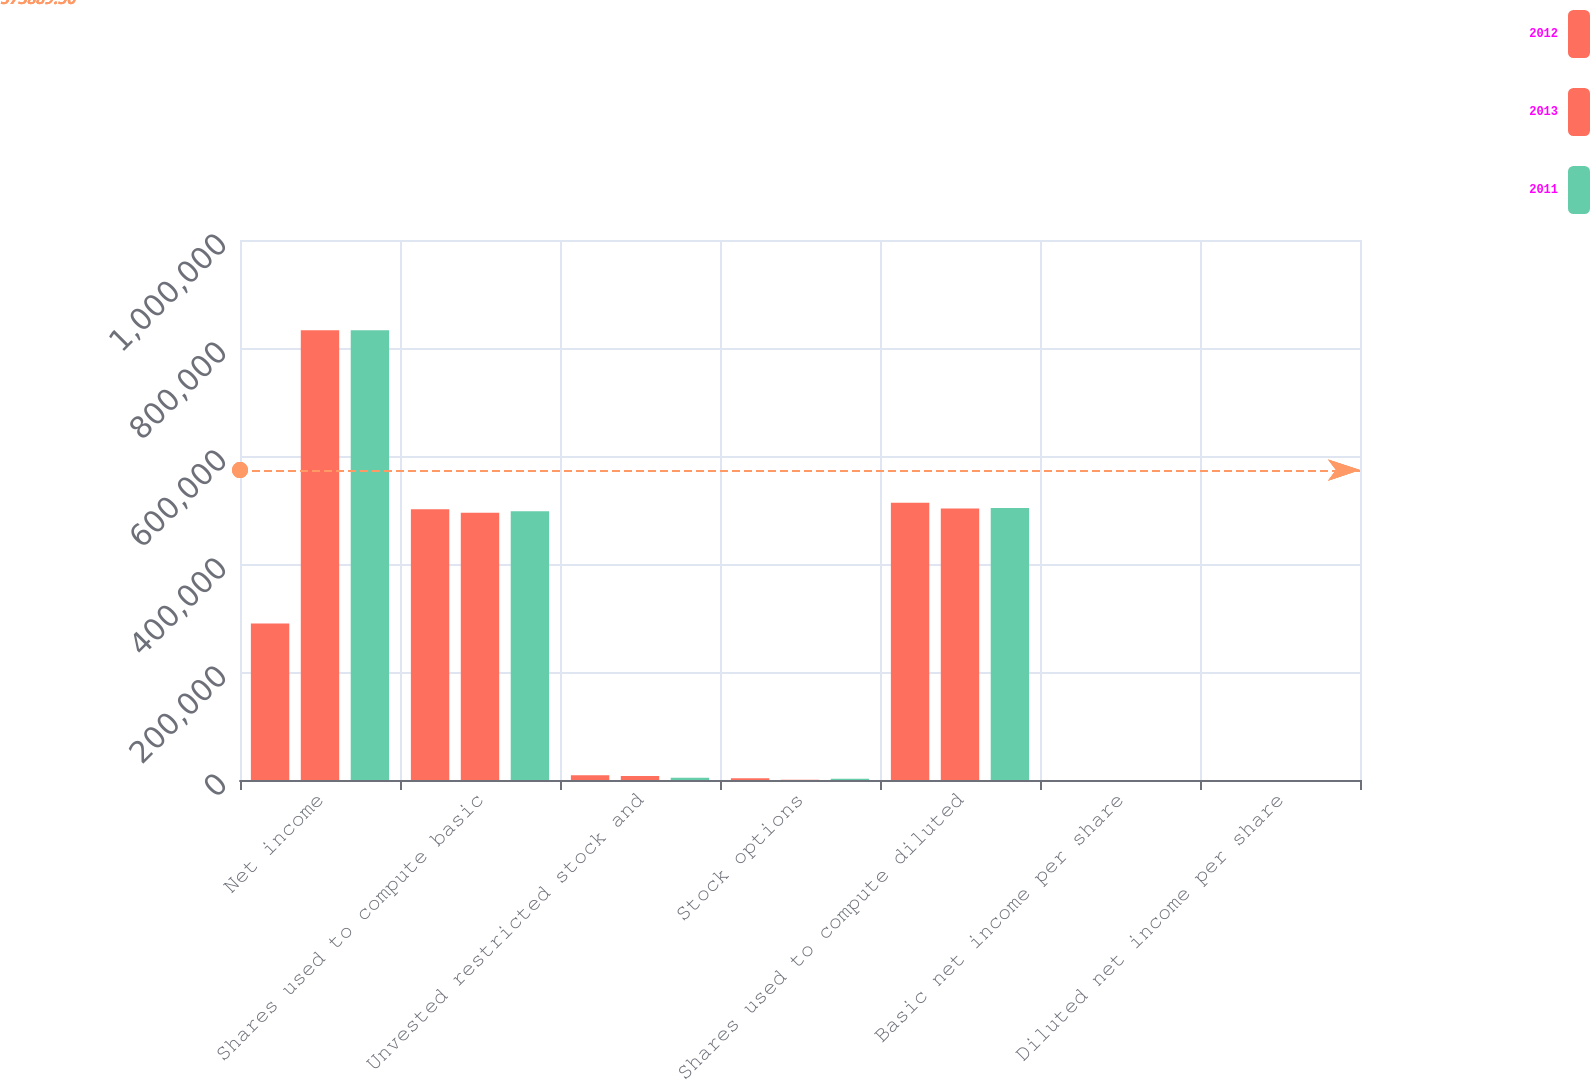<chart> <loc_0><loc_0><loc_500><loc_500><stacked_bar_chart><ecel><fcel>Net income<fcel>Shares used to compute basic<fcel>Unvested restricted stock and<fcel>Stock options<fcel>Shares used to compute diluted<fcel>Basic net income per share<fcel>Diluted net income per share<nl><fcel>2012<fcel>289985<fcel>501372<fcel>8736<fcel>3368<fcel>513476<fcel>0.58<fcel>0.56<nl><fcel>2013<fcel>832775<fcel>494731<fcel>7624<fcel>366<fcel>502721<fcel>1.68<fcel>1.66<nl><fcel>2011<fcel>832847<fcel>497469<fcel>4214<fcel>2238<fcel>503921<fcel>1.67<fcel>1.65<nl></chart> 